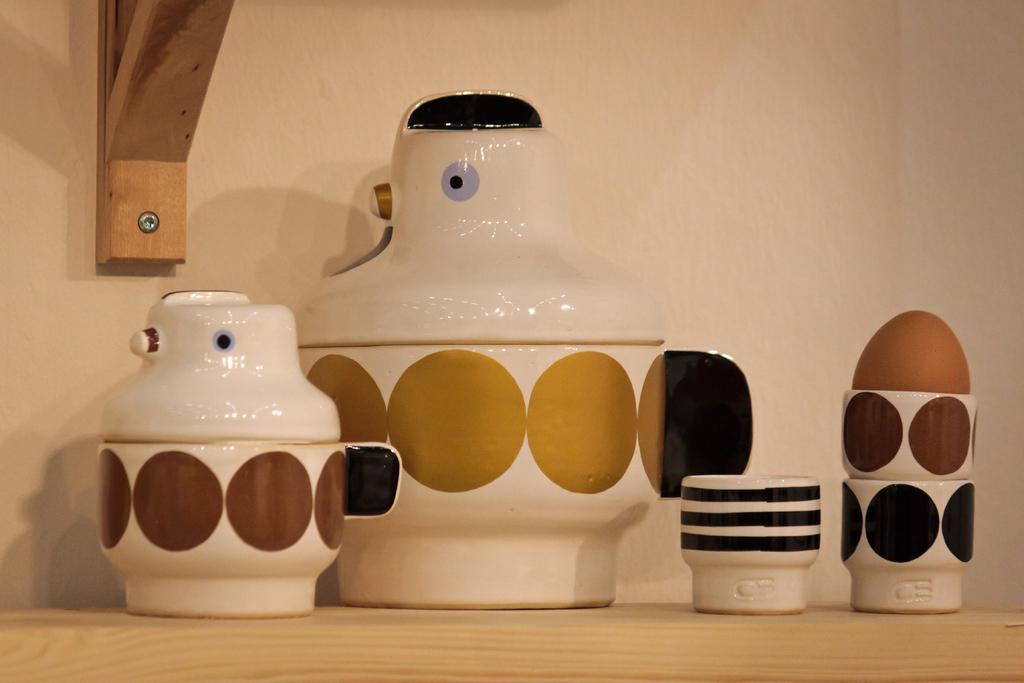Please provide a concise description of this image. In this image there are few crockery items are on the wooden plank. Behind there is a wall having a wooden plank attached to it. 